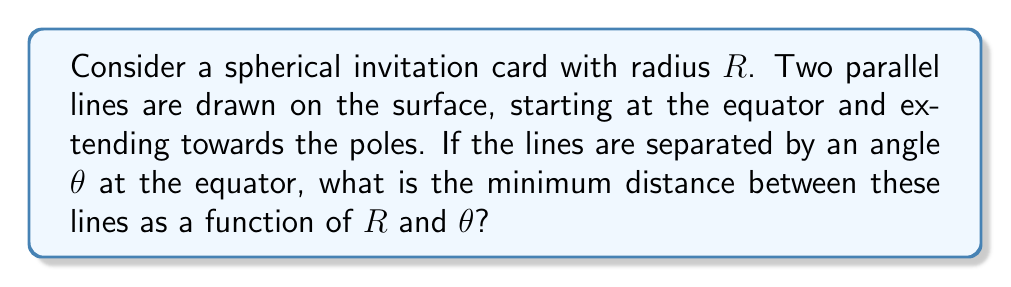Can you answer this question? Let's approach this step-by-step:

1) On a sphere, parallel lines (geodesics) that start at the equator will converge towards the poles. The minimum distance between them will occur at the equator.

2) At the equator, we can consider a small arc of length $s$ that connects the two parallel lines. This arc forms part of a great circle perpendicular to both lines.

3) The angle $\theta$ between the lines at the equator is the same as the central angle subtended by the arc $s$ at the center of the sphere.

4) The relationship between arc length $s$, radius $R$, and central angle $\theta$ (in radians) is:

   $$s = R\theta$$

5) However, $\theta$ is typically given in degrees. We need to convert it to radians:

   $$\theta_{rad} = \frac{\pi}{180^\circ} \cdot \theta_{deg}$$

6) Substituting this into our arc length formula:

   $$s = R \cdot \frac{\pi}{180^\circ} \cdot \theta_{deg}$$

This gives us the minimum distance between the parallel lines on the spherical surface.

[asy]
import geometry;

size(200);
draw(Circle((0,0),1));
draw((-1,0)--(1,0));
draw((0,-1)--(0,1));
draw(arc((0,0),1,0,20),blue);
label("$R$",(0.5,0.5),NE);
label("$\theta$",(0.1,0),N);
label("$s$",(cos(10°),sin(10°)),SE,blue);
[/asy]
Answer: $s = R \cdot \frac{\pi}{180^\circ} \cdot \theta_{deg}$ 